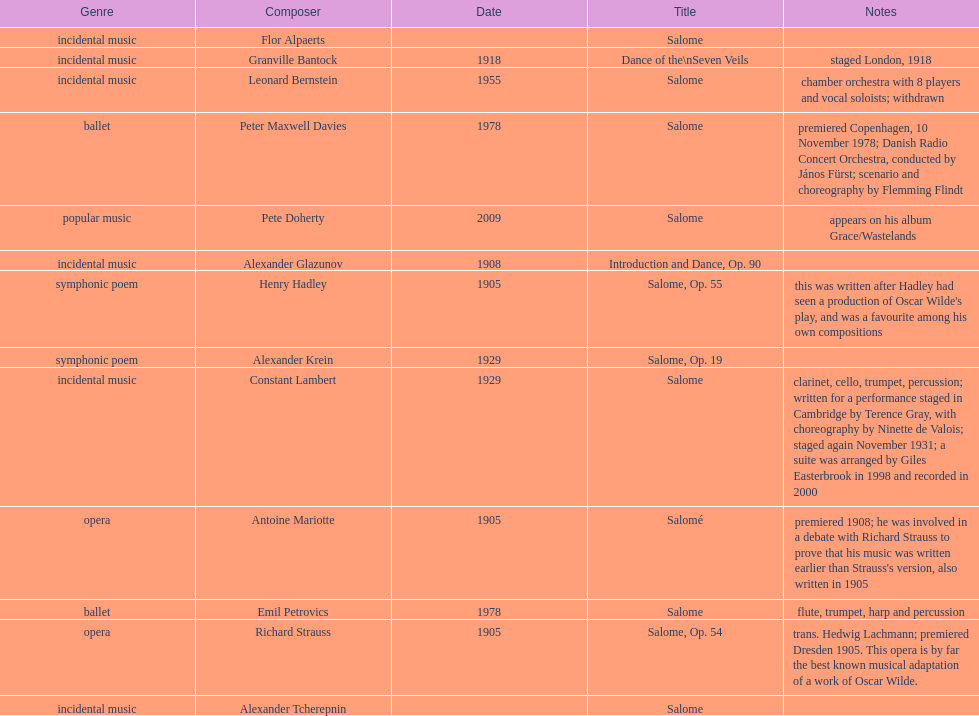What work was written after henry hadley had seen an oscar wilde play? Salome, Op. 55. 